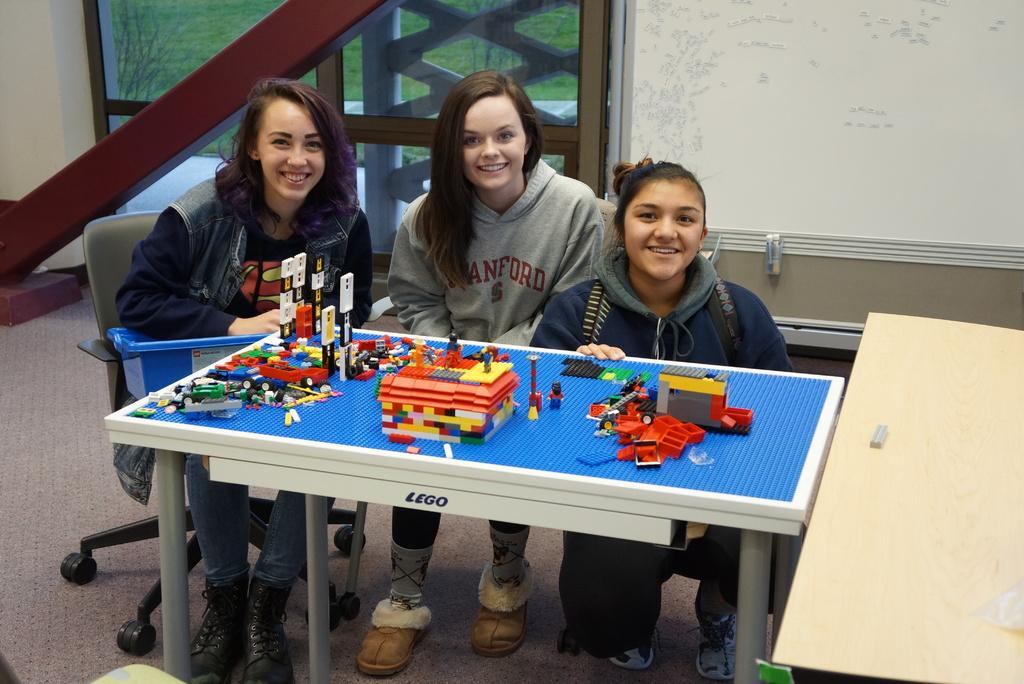How many girls are in the image? There are three girls in the image. What are the girls doing in the image? The girls are posing for a camera. What can be seen on the table in the image? There is a Lego table in the image. What is on the Lego table? There are Lego bricks on the table. What type of houses can be seen in the image? There are no houses present in the image. What type of authority figure can be seen in the image? There is no authority figure present in the image. 